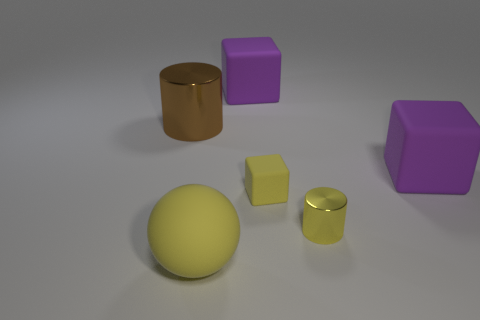Add 2 large matte objects. How many objects exist? 8 Subtract all balls. How many objects are left? 5 Subtract 0 green cubes. How many objects are left? 6 Subtract all tiny cyan objects. Subtract all big matte balls. How many objects are left? 5 Add 3 yellow shiny cylinders. How many yellow shiny cylinders are left? 4 Add 3 large brown shiny cylinders. How many large brown shiny cylinders exist? 4 